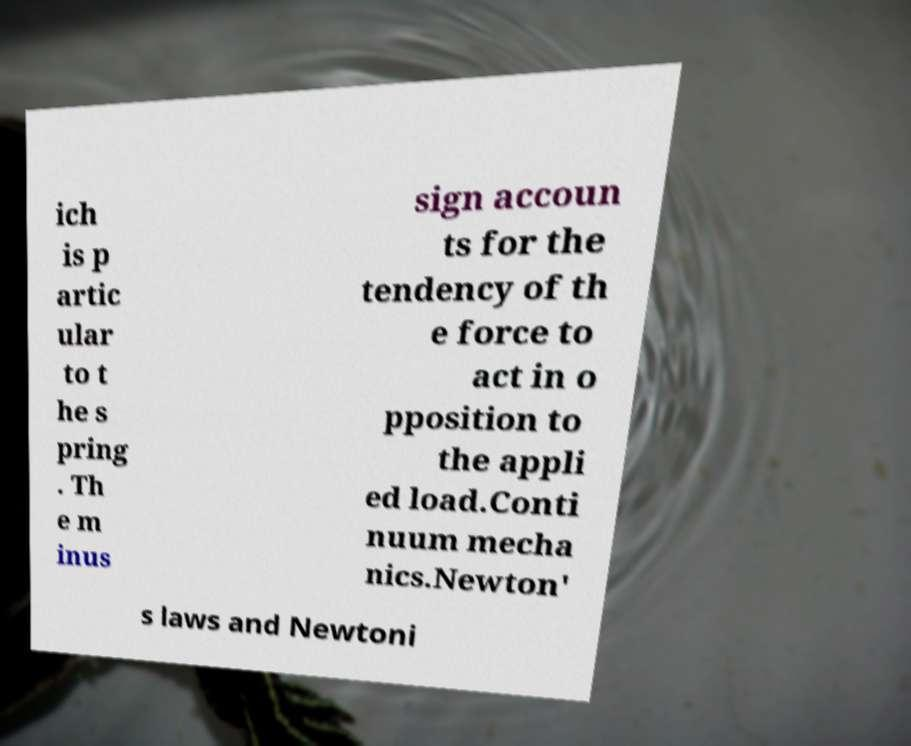For documentation purposes, I need the text within this image transcribed. Could you provide that? ich is p artic ular to t he s pring . Th e m inus sign accoun ts for the tendency of th e force to act in o pposition to the appli ed load.Conti nuum mecha nics.Newton' s laws and Newtoni 